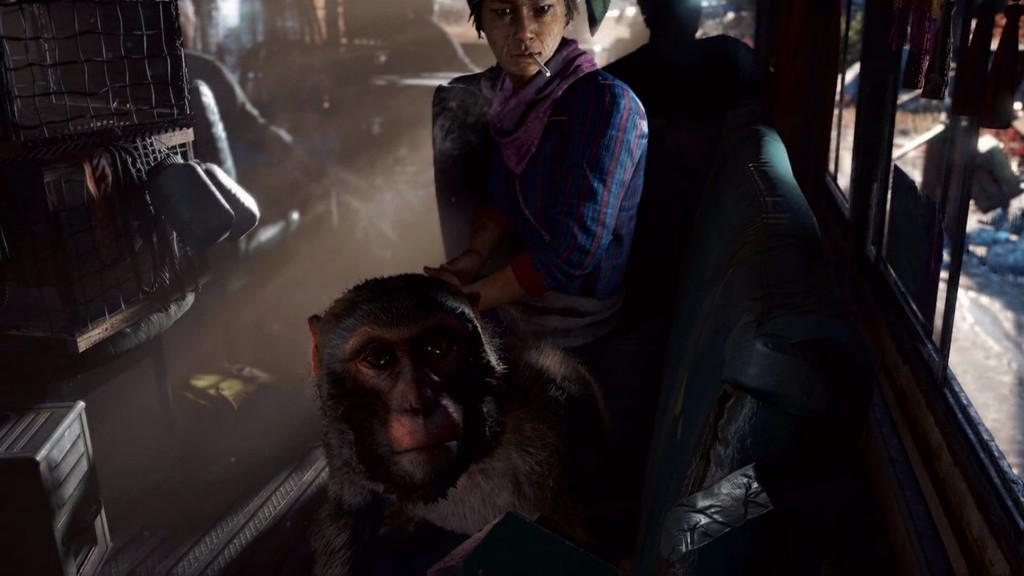Who is present in the image? There is a man and a monkey in the image. What are the man and the monkey doing in the image? Both the man and the monkey are sitting on a chair. What is the man holding in his mouth? The man has a cigarette in his mouth. What other object can be seen in the image? There is a bottle in the image. Can you describe the background of the image? There are people sitting in the background of the image. What type of shade is covering the man and the monkey in the image? There is no shade covering the man and the monkey in the image. What season is it in the image, given the presence of a spring? The image does not depict a specific season, and there is no mention of a spring. 